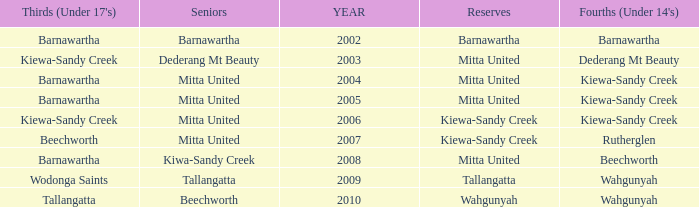Which seniors have a year after 2005, a Reserve of kiewa-sandy creek, and Fourths (Under 14's) of kiewa-sandy creek? Mitta United. 